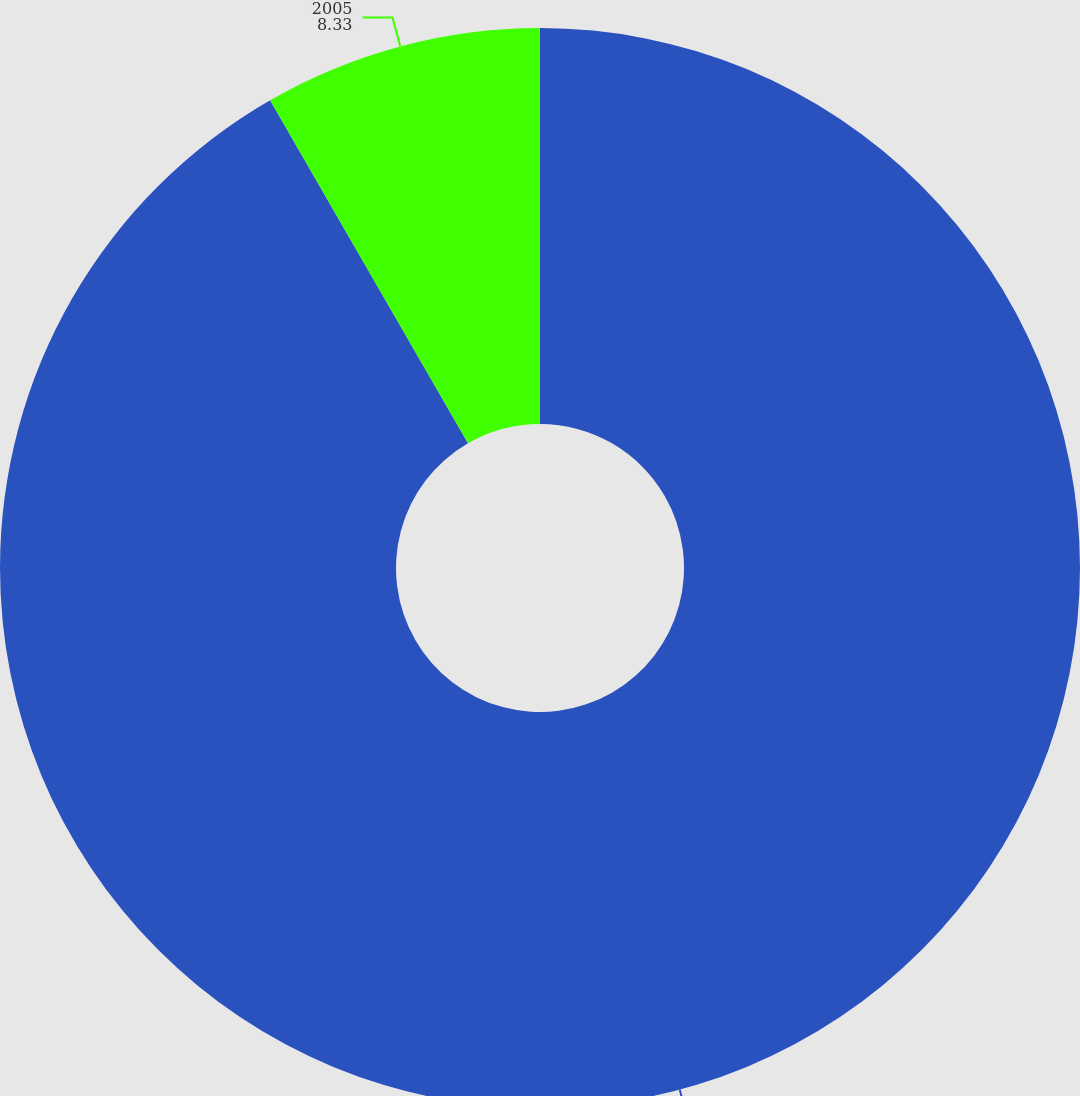Convert chart. <chart><loc_0><loc_0><loc_500><loc_500><pie_chart><fcel>2004<fcel>2005<nl><fcel>91.67%<fcel>8.33%<nl></chart> 